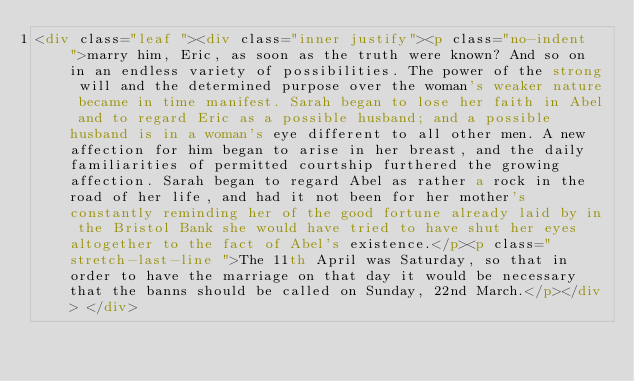<code> <loc_0><loc_0><loc_500><loc_500><_HTML_><div class="leaf "><div class="inner justify"><p class="no-indent  ">marry him, Eric, as soon as the truth were known? And so on in an endless variety of possibilities. The power of the strong will and the determined purpose over the woman's weaker nature became in time manifest. Sarah began to lose her faith in Abel and to regard Eric as a possible husband; and a possible husband is in a woman's eye different to all other men. A new affection for him began to arise in her breast, and the daily familiarities of permitted courtship furthered the growing affection. Sarah began to regard Abel as rather a rock in the road of her life, and had it not been for her mother's constantly reminding her of the good fortune already laid by in the Bristol Bank she would have tried to have shut her eyes altogether to the fact of Abel's existence.</p><p class=" stretch-last-line ">The 11th April was Saturday, so that in order to have the marriage on that day it would be necessary that the banns should be called on Sunday, 22nd March.</p></div> </div></code> 